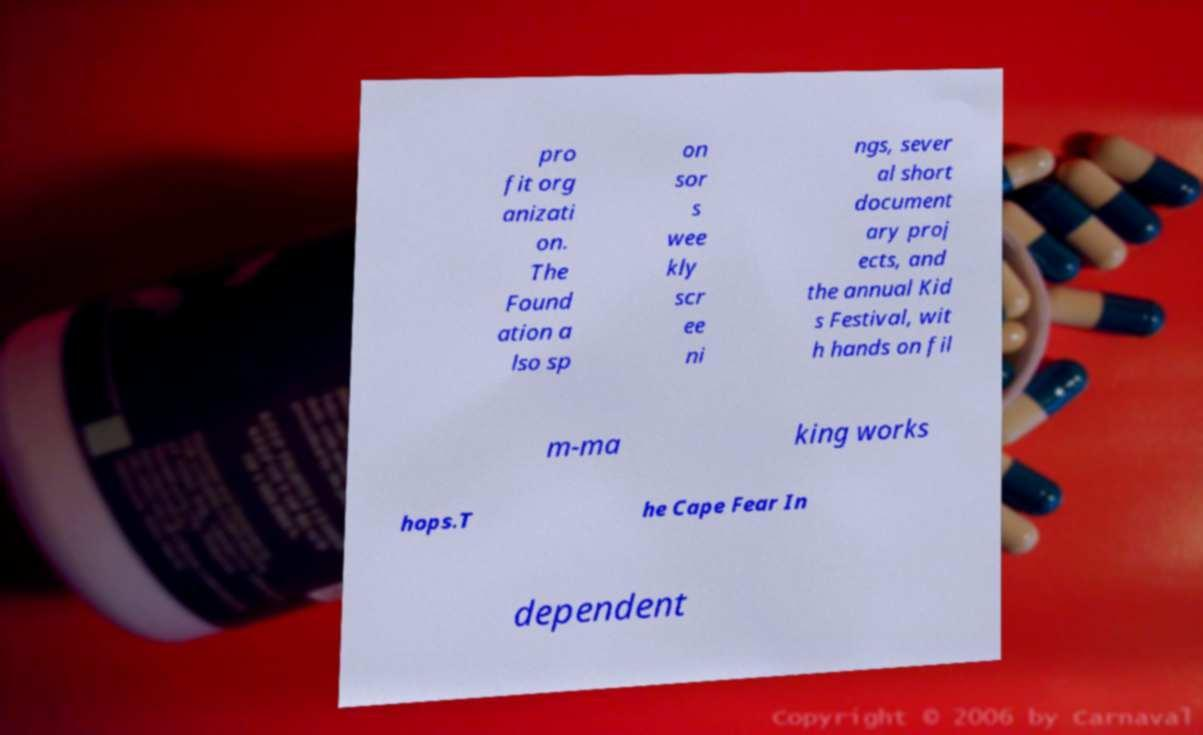Please identify and transcribe the text found in this image. pro fit org anizati on. The Found ation a lso sp on sor s wee kly scr ee ni ngs, sever al short document ary proj ects, and the annual Kid s Festival, wit h hands on fil m-ma king works hops.T he Cape Fear In dependent 